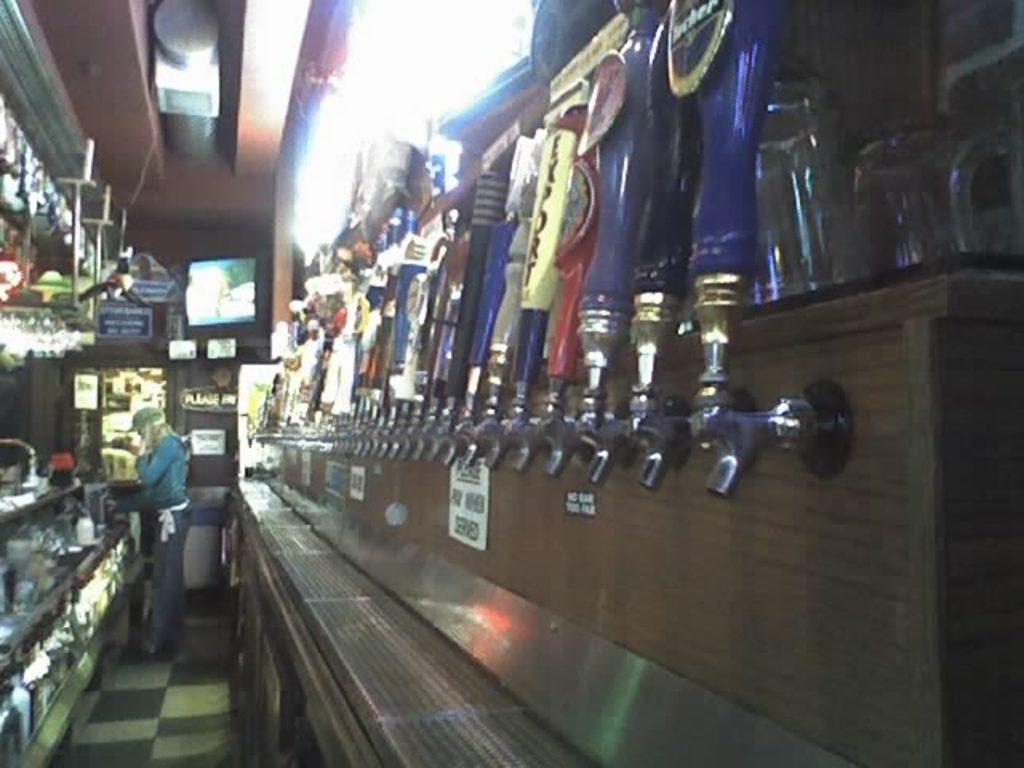What is the main subject of the image? There is a woman standing in the image. Where is the woman standing? The woman is standing on the floor. What can be seen on either side of the woman? There are shelves on either side of the woman. What is on the shelves? There are objects on the shelves. What can be seen in the background of the image? There is a monitor visible in the background of the image. What type of locket is the woman wearing in the image? There is no locket visible on the woman in the image. What instrument is the woman playing in the image? There is no instrument present in the image; the woman is simply standing. 